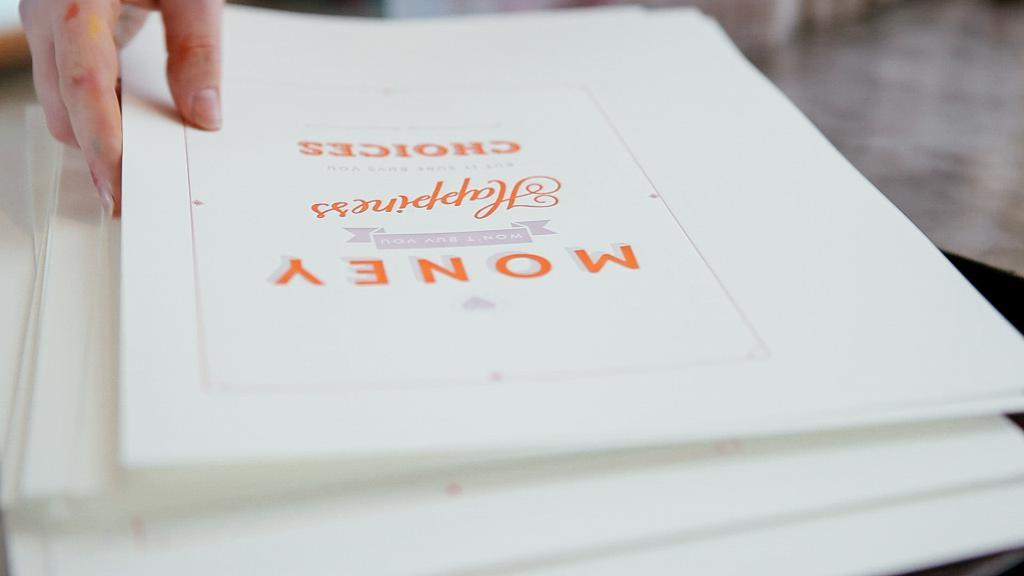Who or what is in the image? There is a person in the image. What is the person doing in the image? The person is touching a white file. How many white files are visible in the image? The white file is on other white files. Where are the files located in the image? The files are on a table. What is the background of the image? The background of the image is the floor. Can you see a goldfish swimming in the background of the image? No, there is no goldfish present in the image. 